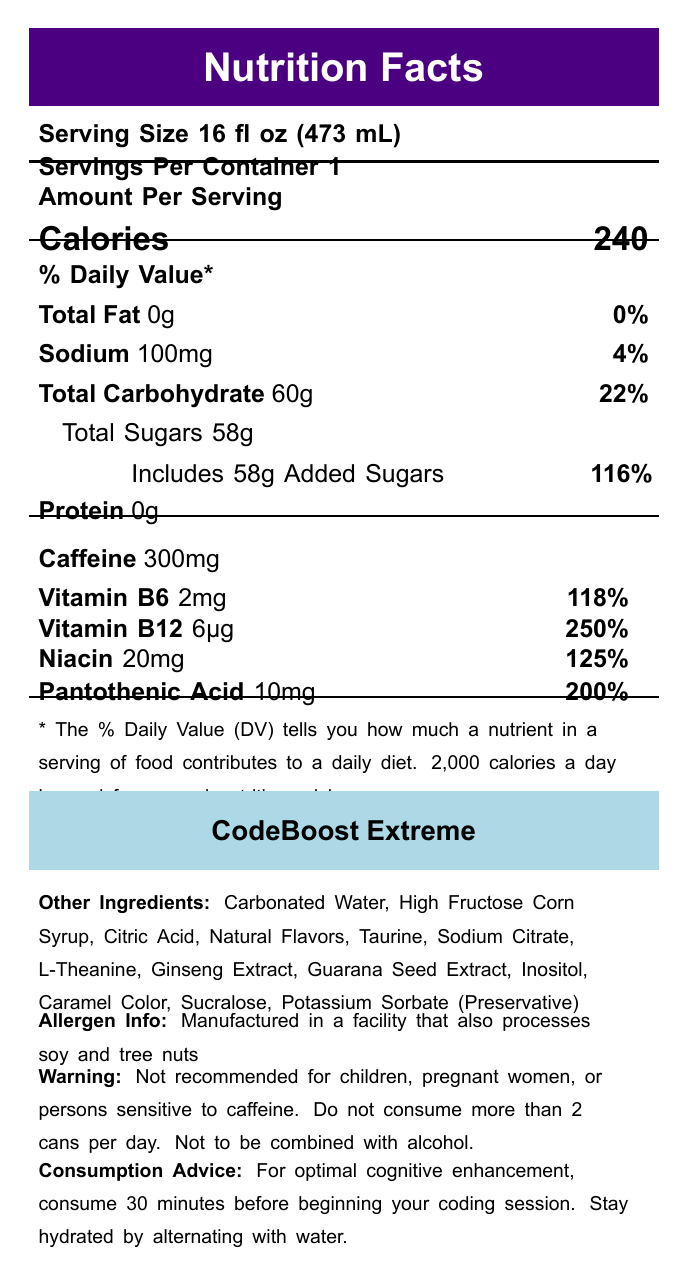what is the serving size? The serving size is listed at the top of the Nutrition Facts section.
Answer: 16 fl oz (473 mL) how many calories are in one serving? The calorie content is shown in the "Amount Per Serving" section.
Answer: 240 what is the total carbohydrate content and its % Daily Value? Both the amount and % Daily Value for total carbohydrate are listed under % Daily Value.
Answer: 60g, 22% how much sodium does the drink contain? The amount of sodium is located under the % Daily Value section.
Answer: 100mg which vitamins and minerals are included in CodeBoost Extreme? The listed vitamins and minerals are found in the nutrition facts label section.
Answer: Vitamin B6, Vitamin B12, Niacin, Pantothenic Acid how much caffeine is in CodeBoost Extreme? The caffeine content is clearly stated under the nutrition facts section.
Answer: 300mg what is the allergen warning associated with this drink? The allergen info section contains this information.
Answer: Manufactured in a facility that also processes soy and tree nuts what are the main ingredients in CodeBoost Extreme? A. Carbonated Water, High Fructose Corn Syrup, Citric Acid B. Taurine, Sodium Citrate, L-Theanine C. Ginseng Extract, Guarana Seed Extract, Inositol All these ingredients are listed under "Other Ingredients."
Answer: A, B, and C how many added sugars are in the drink? A. 50g B. 48g C. 58g D. 60g The document specifies that there are 58g of added sugars.
Answer: C how much Vitamin B12 is in CodeBoost Extreme?  A. 100% B. 200% C. 250% The % Daily Value for Vitamin B12 is 250%, as indicated in the vitamins and minerals section.
Answer: C is this drink suitable for children? The warning section explicitly states that it is not recommended for children.
Answer: No summarize the main purpose of the CodeBoost Extreme drink as per this document. This summary captures the key marketing claims and intended purpose highlighted on the nutrition facts label.
Answer: The main purpose of CodeBoost Extreme is to enhance cognitive function and alertness, supporting extended focus during late-night coding sessions, especially designed for PhD candidates and programmers, formulated with key nutrients to support mental performance. does the drink contain artificial sweeteners? Sucralose, which is an artificial sweetener, is mentioned in the "Other Ingredients" section.
Answer: Yes how many servings are in one container? The serving information at the top of the document indicates this.
Answer: 1 what is the % Daily Value of Pantothenic Acid in CodeBoost Extreme? The % Daily Value for Pantothenic Acid is indicated in the vitamins and minerals section as 200%.
Answer: 200% what is the suggested consumption advice for optimal cognitive enhancement? This information is specified in the consumption advice section.
Answer: Consume 30 minutes before starting a coding session and alternate with water to stay hydrated. can the exact manufacturing location of CodeBoost Extreme be determined based on the document? The document does not provide specific information on the manufacturing location.
Answer: Cannot be determined 